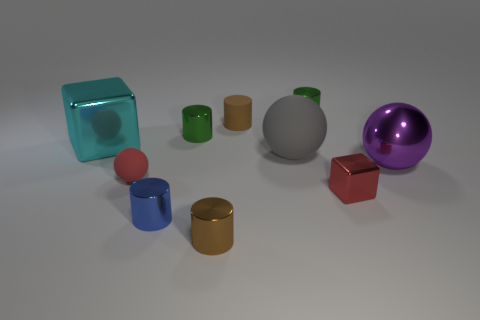Subtract all spheres. How many objects are left? 7 Subtract all tiny matte cylinders. How many cylinders are left? 4 Subtract all red spheres. How many spheres are left? 2 Subtract all red spheres. Subtract all gray blocks. How many spheres are left? 2 Subtract all brown spheres. How many yellow cylinders are left? 0 Subtract all gray matte balls. Subtract all green metal cylinders. How many objects are left? 7 Add 8 tiny red shiny cubes. How many tiny red shiny cubes are left? 9 Add 2 gray metal things. How many gray metal things exist? 2 Subtract 0 green balls. How many objects are left? 10 Subtract 1 spheres. How many spheres are left? 2 